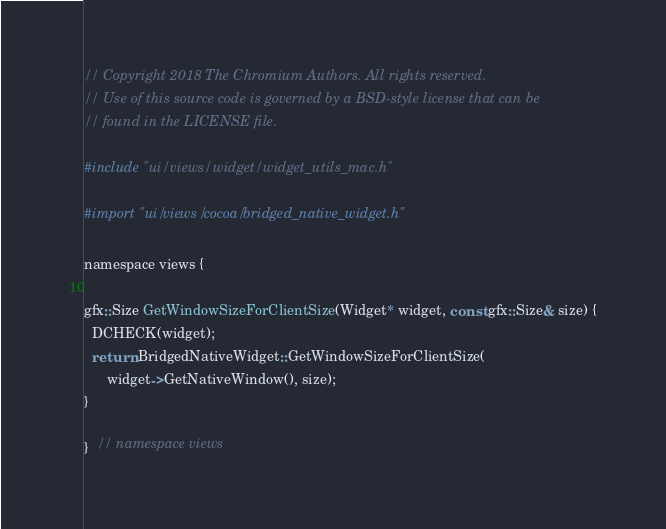<code> <loc_0><loc_0><loc_500><loc_500><_ObjectiveC_>// Copyright 2018 The Chromium Authors. All rights reserved.
// Use of this source code is governed by a BSD-style license that can be
// found in the LICENSE file.

#include "ui/views/widget/widget_utils_mac.h"

#import "ui/views/cocoa/bridged_native_widget.h"

namespace views {

gfx::Size GetWindowSizeForClientSize(Widget* widget, const gfx::Size& size) {
  DCHECK(widget);
  return BridgedNativeWidget::GetWindowSizeForClientSize(
      widget->GetNativeWindow(), size);
}

}  // namespace views
</code> 